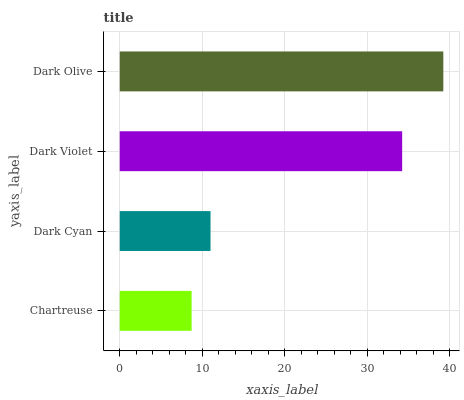Is Chartreuse the minimum?
Answer yes or no. Yes. Is Dark Olive the maximum?
Answer yes or no. Yes. Is Dark Cyan the minimum?
Answer yes or no. No. Is Dark Cyan the maximum?
Answer yes or no. No. Is Dark Cyan greater than Chartreuse?
Answer yes or no. Yes. Is Chartreuse less than Dark Cyan?
Answer yes or no. Yes. Is Chartreuse greater than Dark Cyan?
Answer yes or no. No. Is Dark Cyan less than Chartreuse?
Answer yes or no. No. Is Dark Violet the high median?
Answer yes or no. Yes. Is Dark Cyan the low median?
Answer yes or no. Yes. Is Dark Olive the high median?
Answer yes or no. No. Is Dark Violet the low median?
Answer yes or no. No. 